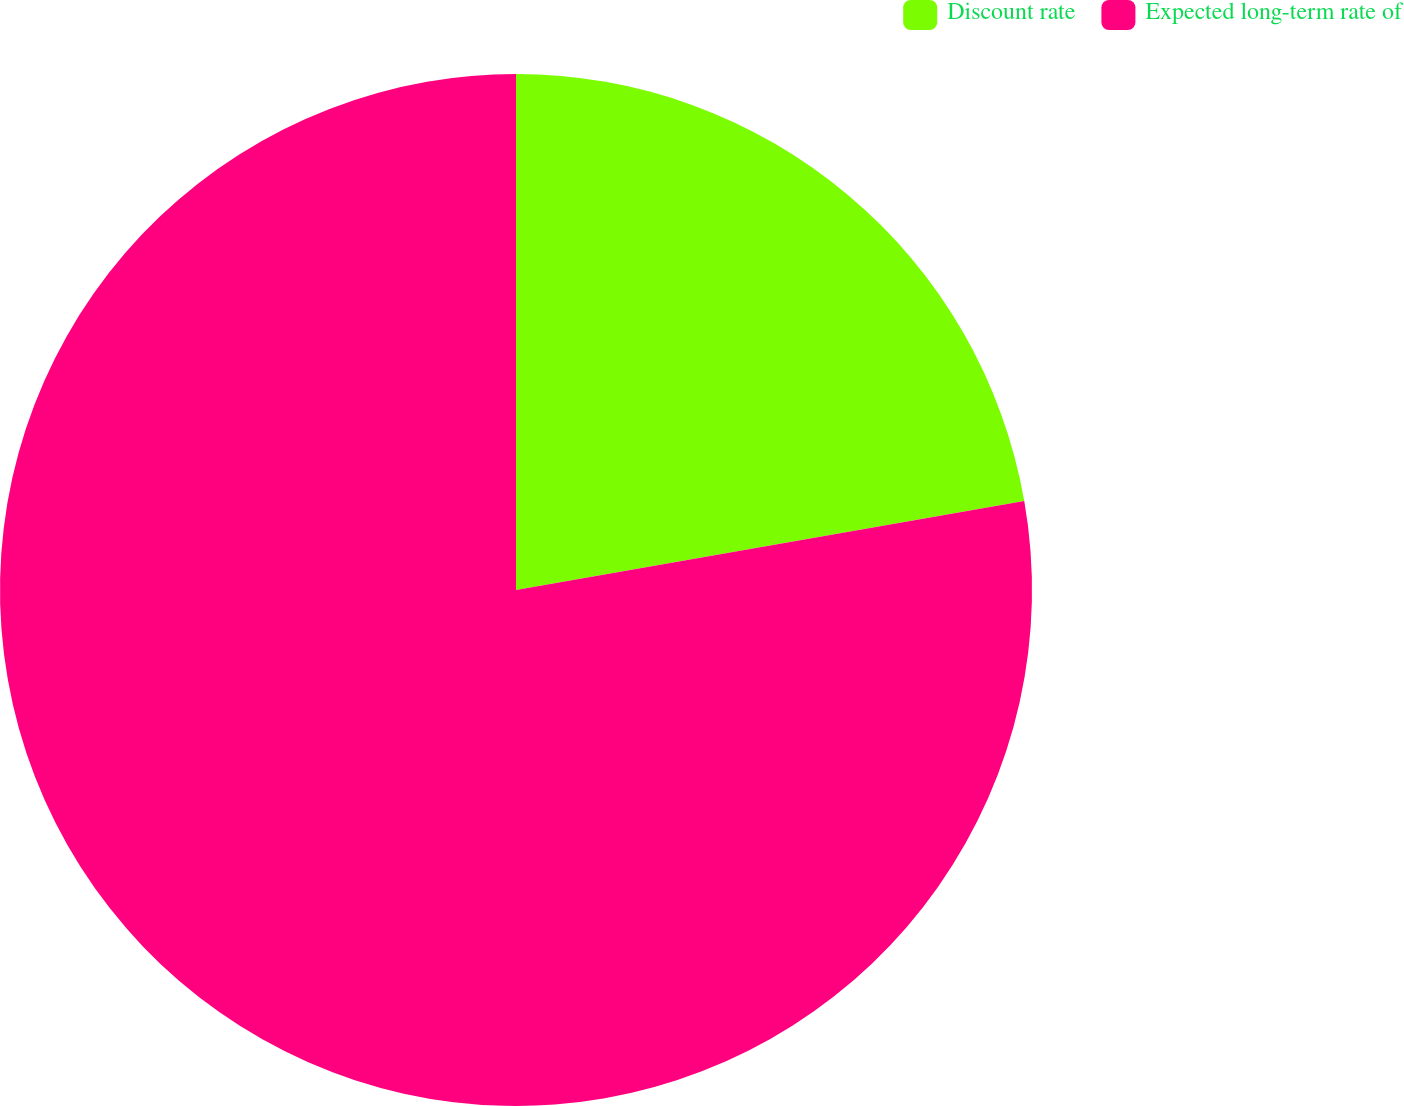Convert chart. <chart><loc_0><loc_0><loc_500><loc_500><pie_chart><fcel>Discount rate<fcel>Expected long-term rate of<nl><fcel>22.24%<fcel>77.76%<nl></chart> 